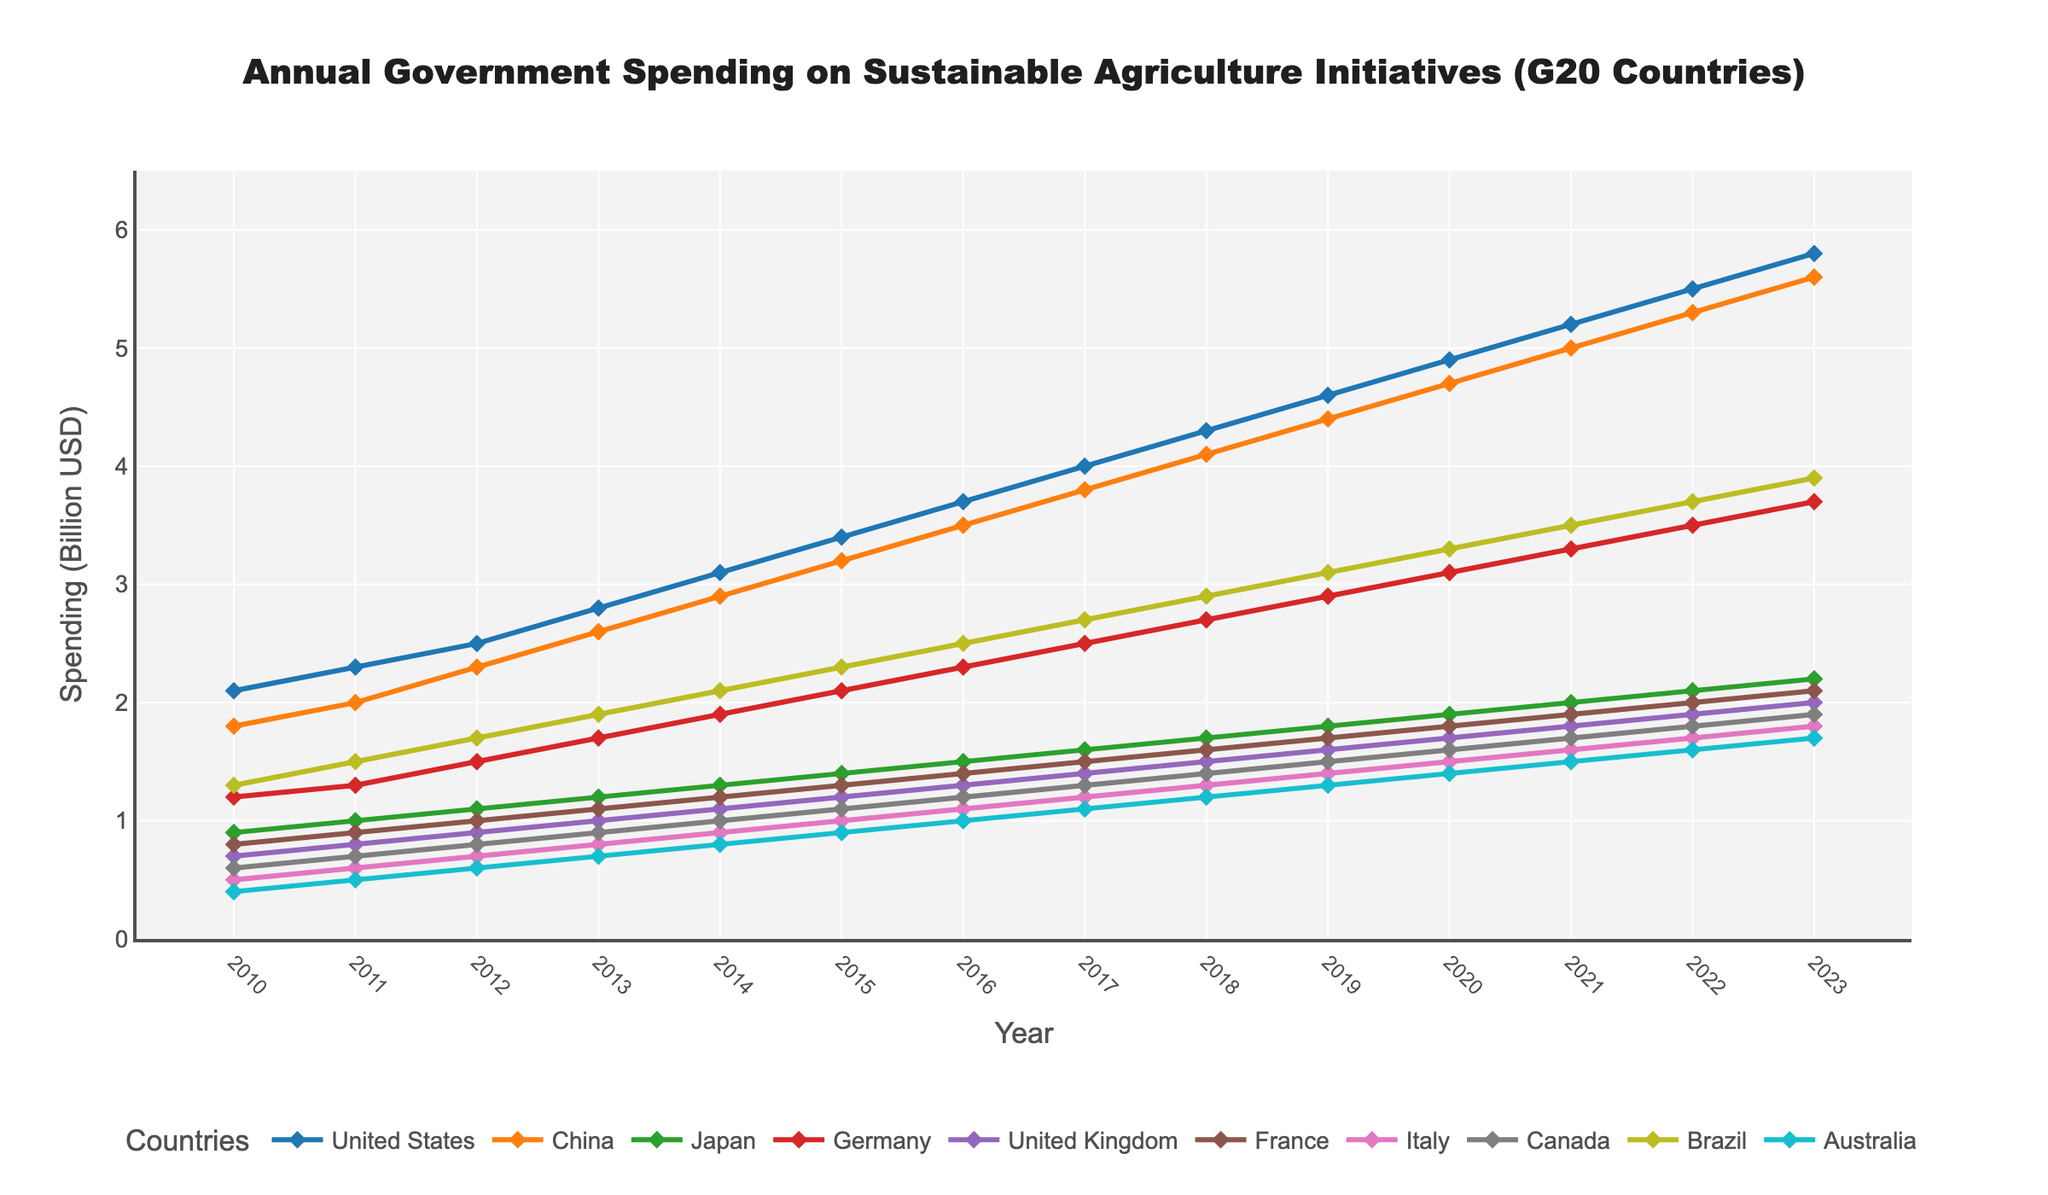Which country had the highest spending on sustainable agriculture in 2023? Look at the data points for 2023 and identify the highest value. The United States has the highest spending at 5.8 billion USD.
Answer: United States Compare the spending on sustainable agriculture in 2012 and 2016 for China. By how much did it increase? Identify the spending values for China in 2012 and 2016, which are 2.3 and 3.5 billion USD respectively. Subtract the 2012 value from the 2016 value: 3.5 - 2.3 = 1.2 billion USD.
Answer: 1.2 billion USD Which country showed a consistent increase in spending every year from 2010 to 2023? Examine the trends for each country from 2010 to 2023. The United States shows a consistent increase in spending without any decline.
Answer: United States What is the average spending on sustainable agriculture initiatives for Germany from 2010 to 2023? Sum the annual spending values for Germany and divide by the number of years (14). The values are [1.2, 1.3, 1.5, 1.7, 1.9, 2.1, 2.3, 2.5, 2.7, 2.9, 3.1, 3.3, 3.5, 3.7]. The sum is 35.8, and the average is \( \frac{35.8}{14} = 2.56 \) billion USD.
Answer: 2.56 billion USD Which country had the least spending increase from 2017 to 2023? By how much did it increase? Compare the differences in spending for all countries between 2017 and 2023. For Japan, it increased from 1.6 to 2.2 billion USD. Calculate the difference: 2.2 - 1.6 = 0.6 billion USD. No other countries show a smaller increase.
Answer: Japan, 0.6 billion USD How much more did France spend on sustainable agriculture in 2023 compared to the United Kingdom in 2018? Identify the value for France in 2023 (2.1 billion USD) and the United Kingdom in 2018 (1.5 billion USD). Subtract the two: 2.1 - 1.5 = 0.6 billion USD.
Answer: 0.6 billion USD Which country had the most rapid increase in spending from 2010 to 2023? Identify the initial and final spending levels for each country and calculate the difference. The United States increased from 2.1 to 5.8 billion USD, a change of 3.7 billion USD, which is the highest among all countries.
Answer: United States Does any country show a decrease in spending in any year within the given period? Check the data for any decreases year-over-year. None of the countries show a decrease in any given year, they all show an increasing trend.
Answer: No 